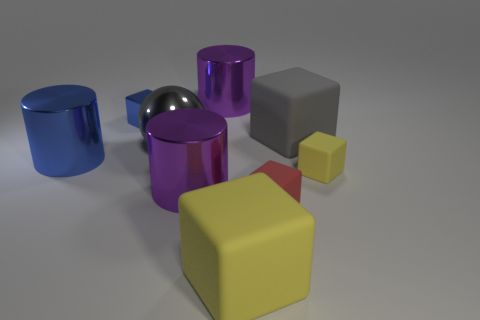Subtract all blue metallic cylinders. How many cylinders are left? 2 Subtract all yellow blocks. How many purple cylinders are left? 2 Subtract all blue cylinders. How many cylinders are left? 2 Subtract 1 cylinders. How many cylinders are left? 2 Add 1 red rubber objects. How many objects exist? 10 Subtract all cyan cylinders. Subtract all yellow spheres. How many cylinders are left? 3 Subtract 1 gray spheres. How many objects are left? 8 Subtract all blocks. How many objects are left? 4 Subtract all small yellow metal cubes. Subtract all yellow objects. How many objects are left? 7 Add 6 red rubber things. How many red rubber things are left? 7 